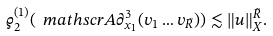Convert formula to latex. <formula><loc_0><loc_0><loc_500><loc_500>\varrho ^ { ( 1 ) } _ { 2 } ( \ m a t h s c r { A } \partial ^ { 3 } _ { x _ { 1 } } ( v _ { 1 } \dots v _ { \tilde { R } } ) ) & \lesssim \| u \| ^ { \tilde { R } } _ { X } .</formula> 